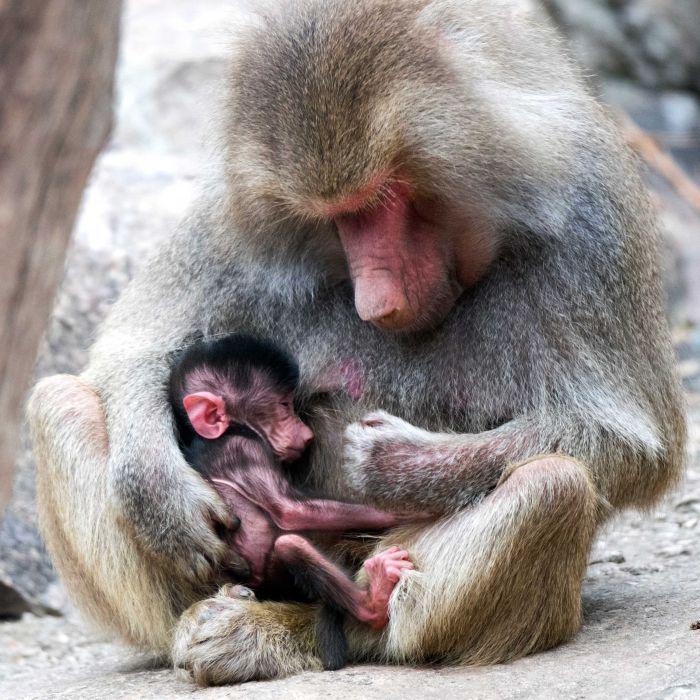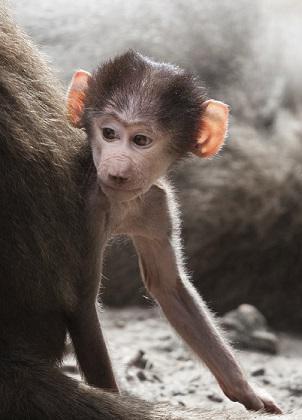The first image is the image on the left, the second image is the image on the right. Examine the images to the left and right. Is the description "No monkey is photographed alone." accurate? Answer yes or no. No. 